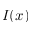Convert formula to latex. <formula><loc_0><loc_0><loc_500><loc_500>I ( x )</formula> 